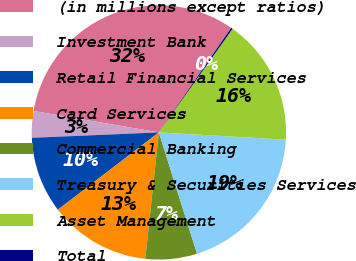Convert chart. <chart><loc_0><loc_0><loc_500><loc_500><pie_chart><fcel>(in millions except ratios)<fcel>Investment Bank<fcel>Retail Financial Services<fcel>Card Services<fcel>Commercial Banking<fcel>Treasury & Securities Services<fcel>Asset Management<fcel>Total<nl><fcel>31.93%<fcel>3.38%<fcel>9.72%<fcel>12.9%<fcel>6.55%<fcel>19.24%<fcel>16.07%<fcel>0.21%<nl></chart> 